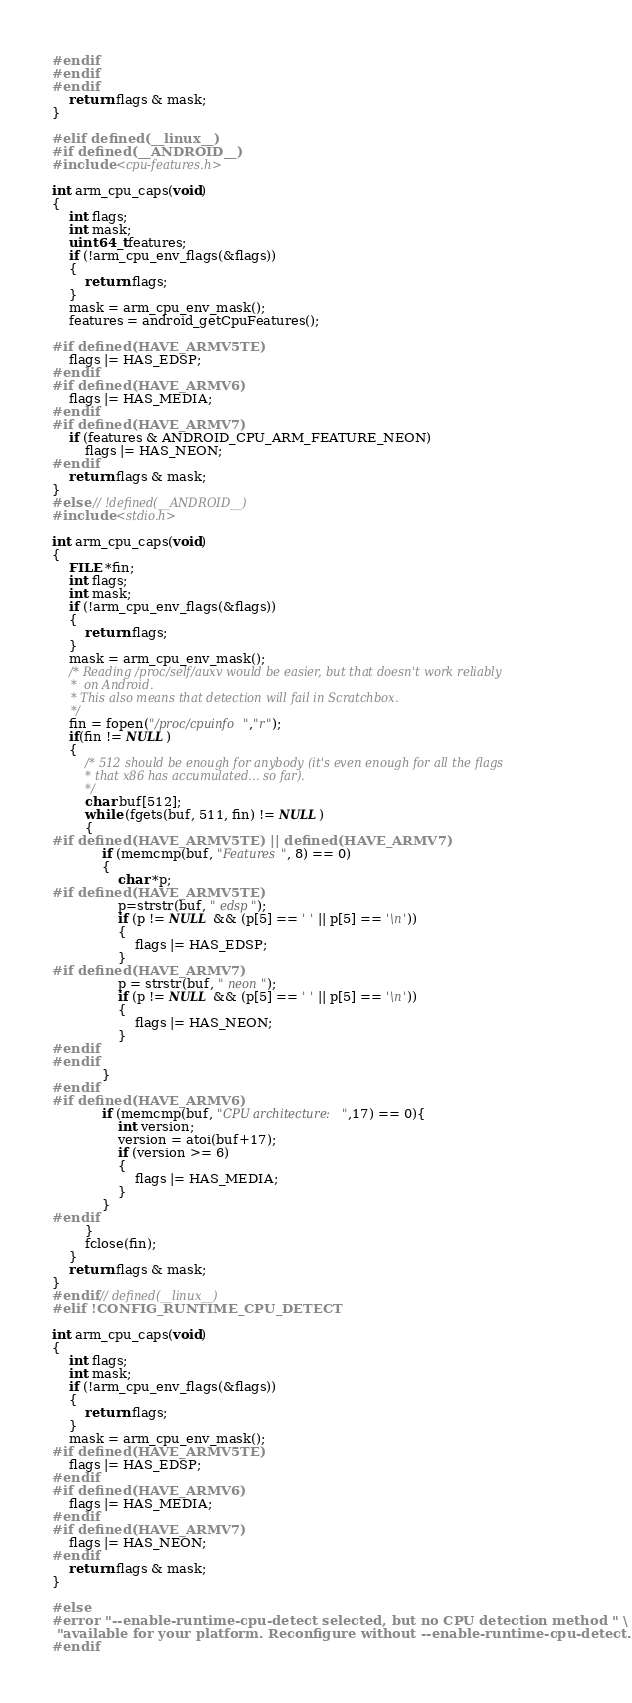Convert code to text. <code><loc_0><loc_0><loc_500><loc_500><_C_>#endif
#endif
#endif
    return flags & mask;
}

#elif defined(__linux__)
#if defined(__ANDROID__)
#include <cpu-features.h>

int arm_cpu_caps(void)
{
    int flags;
    int mask;
    uint64_t features;
    if (!arm_cpu_env_flags(&flags))
    {
        return flags;
    }
    mask = arm_cpu_env_mask();
    features = android_getCpuFeatures();

#if defined(HAVE_ARMV5TE)
    flags |= HAS_EDSP;
#endif
#if defined(HAVE_ARMV6)
    flags |= HAS_MEDIA;
#endif
#if defined(HAVE_ARMV7)
    if (features & ANDROID_CPU_ARM_FEATURE_NEON)
        flags |= HAS_NEON;
#endif
    return flags & mask;
}
#else // !defined(__ANDROID__)
#include <stdio.h>

int arm_cpu_caps(void)
{
    FILE *fin;
    int flags;
    int mask;
    if (!arm_cpu_env_flags(&flags))
    {
        return flags;
    }
    mask = arm_cpu_env_mask();
    /* Reading /proc/self/auxv would be easier, but that doesn't work reliably
     *  on Android.
     * This also means that detection will fail in Scratchbox.
     */
    fin = fopen("/proc/cpuinfo","r");
    if(fin != NULL)
    {
        /* 512 should be enough for anybody (it's even enough for all the flags
         * that x86 has accumulated... so far).
         */
        char buf[512];
        while (fgets(buf, 511, fin) != NULL)
        {
#if defined(HAVE_ARMV5TE) || defined(HAVE_ARMV7)
            if (memcmp(buf, "Features", 8) == 0)
            {
                char *p;
#if defined(HAVE_ARMV5TE)
                p=strstr(buf, " edsp");
                if (p != NULL && (p[5] == ' ' || p[5] == '\n'))
                {
                    flags |= HAS_EDSP;
                }
#if defined(HAVE_ARMV7)
                p = strstr(buf, " neon");
                if (p != NULL && (p[5] == ' ' || p[5] == '\n'))
                {
                    flags |= HAS_NEON;
                }
#endif
#endif
            }
#endif
#if defined(HAVE_ARMV6)
            if (memcmp(buf, "CPU architecture:",17) == 0){
                int version;
                version = atoi(buf+17);
                if (version >= 6)
                {
                    flags |= HAS_MEDIA;
                }
            }
#endif
        }
        fclose(fin);
    }
    return flags & mask;
}
#endif // defined(__linux__)
#elif !CONFIG_RUNTIME_CPU_DETECT

int arm_cpu_caps(void)
{
    int flags;
    int mask;
    if (!arm_cpu_env_flags(&flags))
    {
        return flags;
    }
    mask = arm_cpu_env_mask();
#if defined(HAVE_ARMV5TE)
    flags |= HAS_EDSP;
#endif
#if defined(HAVE_ARMV6)
    flags |= HAS_MEDIA;
#endif
#if defined(HAVE_ARMV7)
    flags |= HAS_NEON;
#endif
    return flags & mask;
}

#else
#error "--enable-runtime-cpu-detect selected, but no CPU detection method " \
 "available for your platform. Reconfigure without --enable-runtime-cpu-detect."
#endif
</code> 